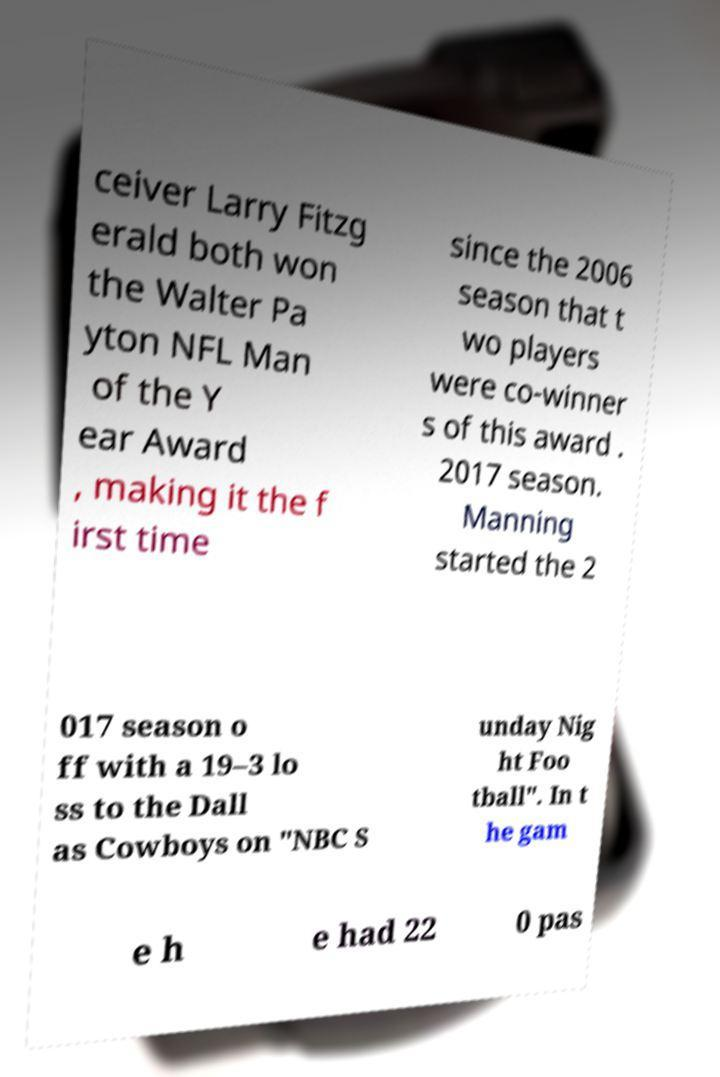What messages or text are displayed in this image? I need them in a readable, typed format. ceiver Larry Fitzg erald both won the Walter Pa yton NFL Man of the Y ear Award , making it the f irst time since the 2006 season that t wo players were co-winner s of this award . 2017 season. Manning started the 2 017 season o ff with a 19–3 lo ss to the Dall as Cowboys on "NBC S unday Nig ht Foo tball". In t he gam e h e had 22 0 pas 